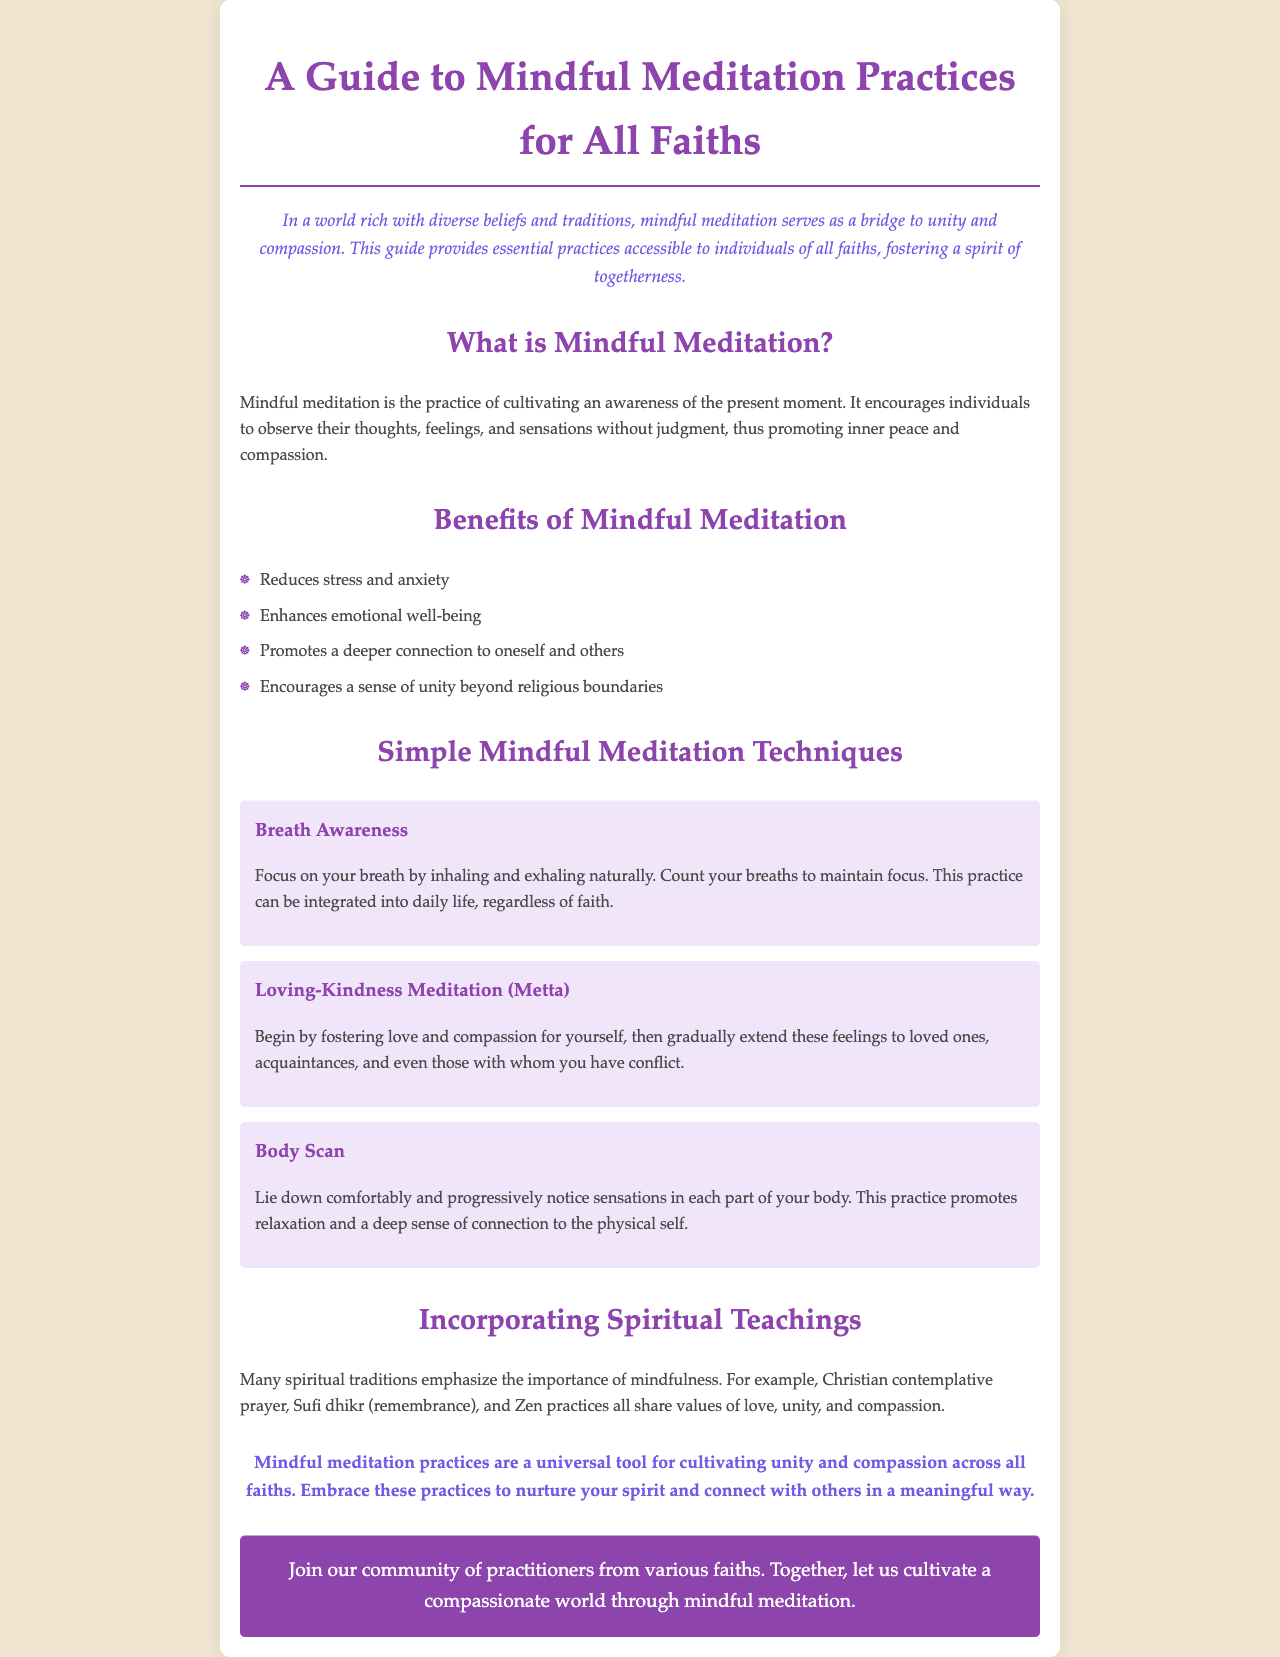What is the title of the brochure? The title of the brochure is presented prominently at the top of the document.
Answer: A Guide to Mindful Meditation Practices for All Faiths What is the main purpose of the guide? The purpose is outlined in the introduction where it speaks about unity and compassion across diverse beliefs.
Answer: To foster a spirit of togetherness How many mindful meditation techniques are mentioned? The document lists the techniques under a specific heading, providing three examples of techniques.
Answer: Three What is the first technique described? The first technique is detailed in a separate section that highlights its name and description.
Answer: Breath Awareness Which meditation technique promotes compassion towards oneself and others? The document specifies this technique when discussing fostering feelings of love and compassion.
Answer: Loving-Kindness Meditation (Metta) What does a Body Scan practice involve? The document explains this practice in the context of noticing sensations in parts of the body.
Answer: Noticing sensations in each part of your body Which spiritual traditions are mentioned that emphasize mindfulness? The brochure lists specific spiritual practices that share similar values, providing examples in the text.
Answer: Christian contemplative prayer, Sufi dhikr, Zen practices What is emphasized as a result of practicing mindful meditation? The conclusion summarizes the overarching benefit of these practices, aiming at connection and compassion.
Answer: Unity and compassion What call to action is presented at the end of the document? The call to action encourages community engagement and collective effort in practice.
Answer: Join our community of practitioners from various faiths 